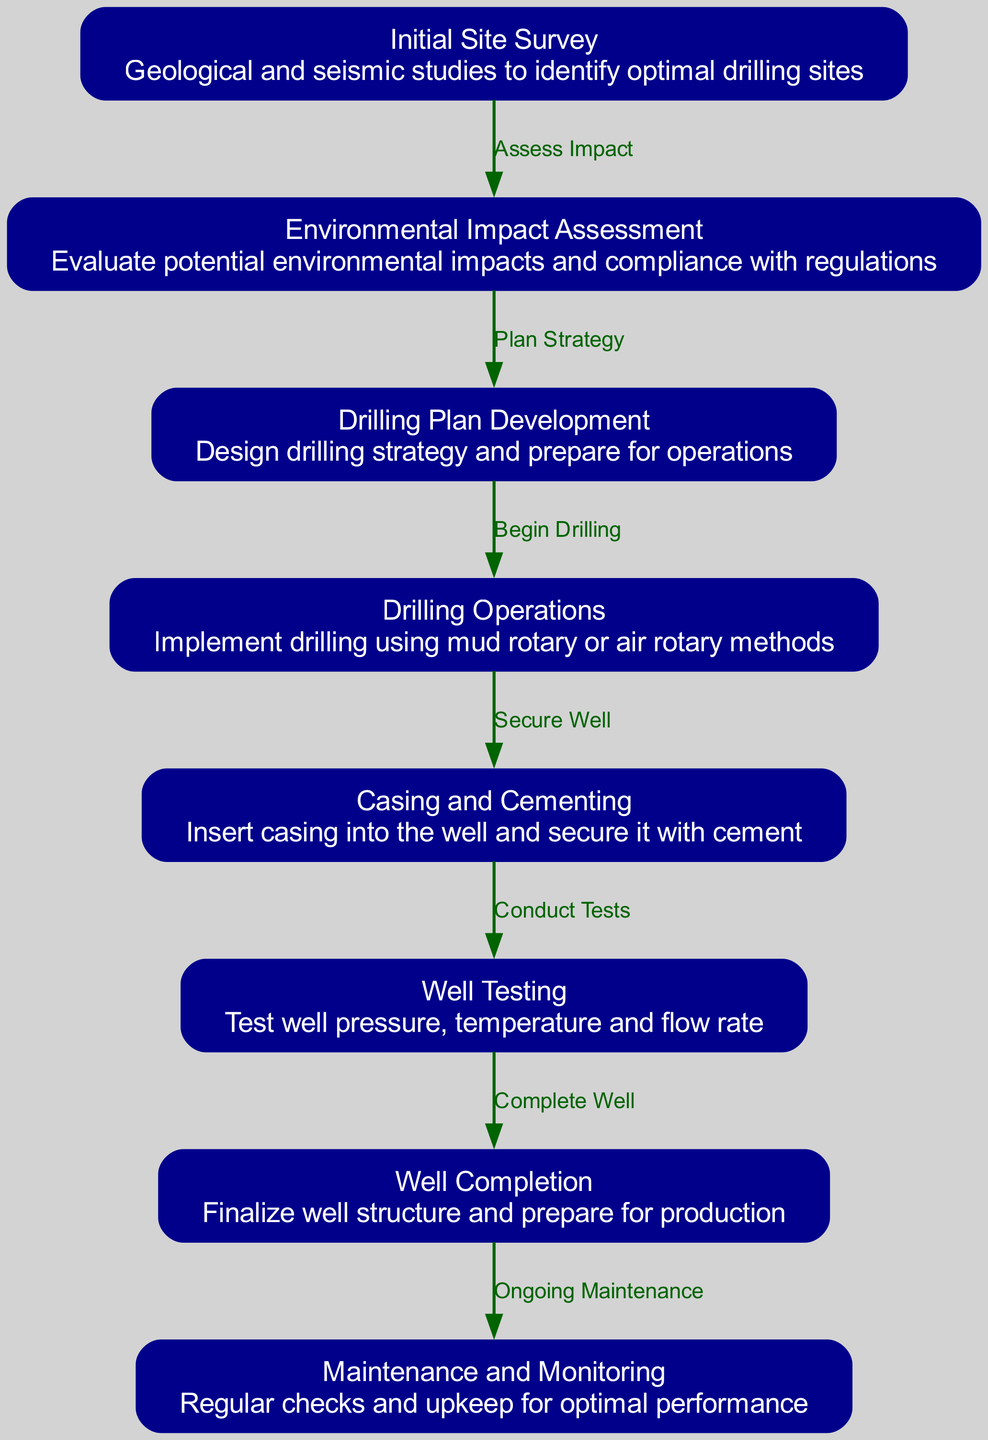What is the first stage in the geothermal drilling lifecycle? The diagram shows "Initial Site Survey" as the start of the lifecycle, indicating this is the first stage.
Answer: Initial Site Survey How many nodes are present in the diagram? By counting the individual stages in the diagram, there are a total of 8 nodes that represent different stages of geothermal drilling operations.
Answer: 8 What stage comes after "Well Testing"? The arrow leading from "Well Testing" points to "Well Completion," indicating this is the next stage in the process.
Answer: Well Completion What is the label for the node that assesses potential environmental impacts? The node labeled "Environmental Impact Assessment" is specifically focused on this evaluation, as described in the diagram.
Answer: Environmental Impact Assessment Which stage involves security measures for the well? The "Casing and Cementing" stage is concerned with ensuring the well's structural integrity by inserting casing and securing it with cement.
Answer: Casing and Cementing What action is linked to "Drilling Plan Development"? The arrow from "Drilling Plan Development" to "Drilling Operations" indicates that the action is to "Begin Drilling," which is derived from the planning stage.
Answer: Begin Drilling Which node indicates ongoing procedures after well completion? The last stage directs to "Maintenance and Monitoring," clearly indicating that this stage involves ongoing procedures to ensure optimal well performance.
Answer: Maintenance and Monitoring What type of studies are conducted during the initial site survey? The diagram describes this stage as involving "Geological and seismic studies," which helps in identifying the right drilling locations.
Answer: Geological and seismic studies What process follows securing the well? The diagram directly connects "Casing and Cementing" to "Well Testing," indicating that testing processes follow securing the well.
Answer: Well Testing 